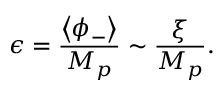<formula> <loc_0><loc_0><loc_500><loc_500>\epsilon = \frac { \left < \phi _ { - } \right > } { M _ { p } } \sim \frac { \xi } { M _ { p } } .</formula> 